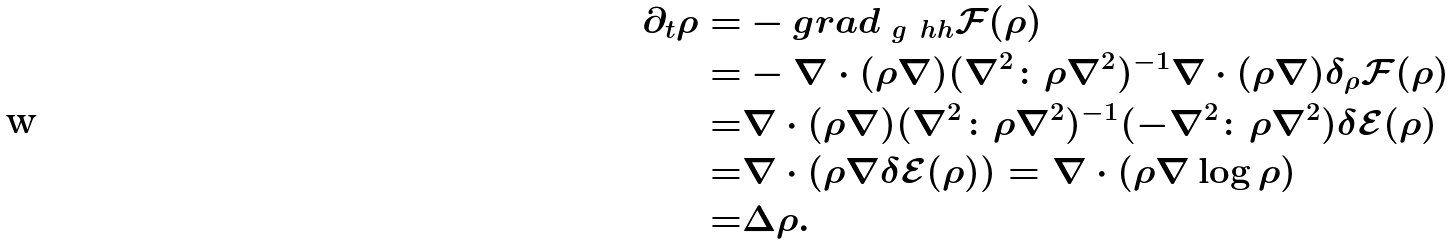Convert formula to latex. <formula><loc_0><loc_0><loc_500><loc_500>\partial _ { t } \rho = & - g r a d _ { \ g ^ { \ } h h } \mathcal { F } ( \rho ) \\ = & - \nabla \cdot ( \rho \nabla ) ( \nabla ^ { 2 } \colon \rho \nabla ^ { 2 } ) ^ { - 1 } \nabla \cdot ( \rho \nabla ) \delta _ { \rho } \mathcal { F } ( \rho ) \\ = & \nabla \cdot ( \rho \nabla ) ( \nabla ^ { 2 } \colon \rho \nabla ^ { 2 } ) ^ { - 1 } ( - \nabla ^ { 2 } \colon \rho \nabla ^ { 2 } ) \delta \mathcal { E } ( \rho ) \\ = & \nabla \cdot ( \rho \nabla \delta \mathcal { E } ( \rho ) ) = \nabla \cdot ( \rho \nabla \log \rho ) \\ = & \Delta \rho .</formula> 